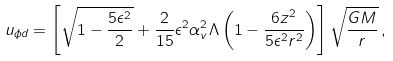Convert formula to latex. <formula><loc_0><loc_0><loc_500><loc_500>u _ { \phi d } = \left [ \sqrt { 1 - \frac { 5 \epsilon ^ { 2 } } { 2 } } + \frac { 2 } { 1 5 } \epsilon ^ { 2 } \alpha ^ { 2 } _ { v } \Lambda \left ( 1 - \frac { 6 z ^ { 2 } } { 5 \epsilon ^ { 2 } r ^ { 2 } } \right ) \right ] \sqrt { \frac { G M } { r } } \, ,</formula> 